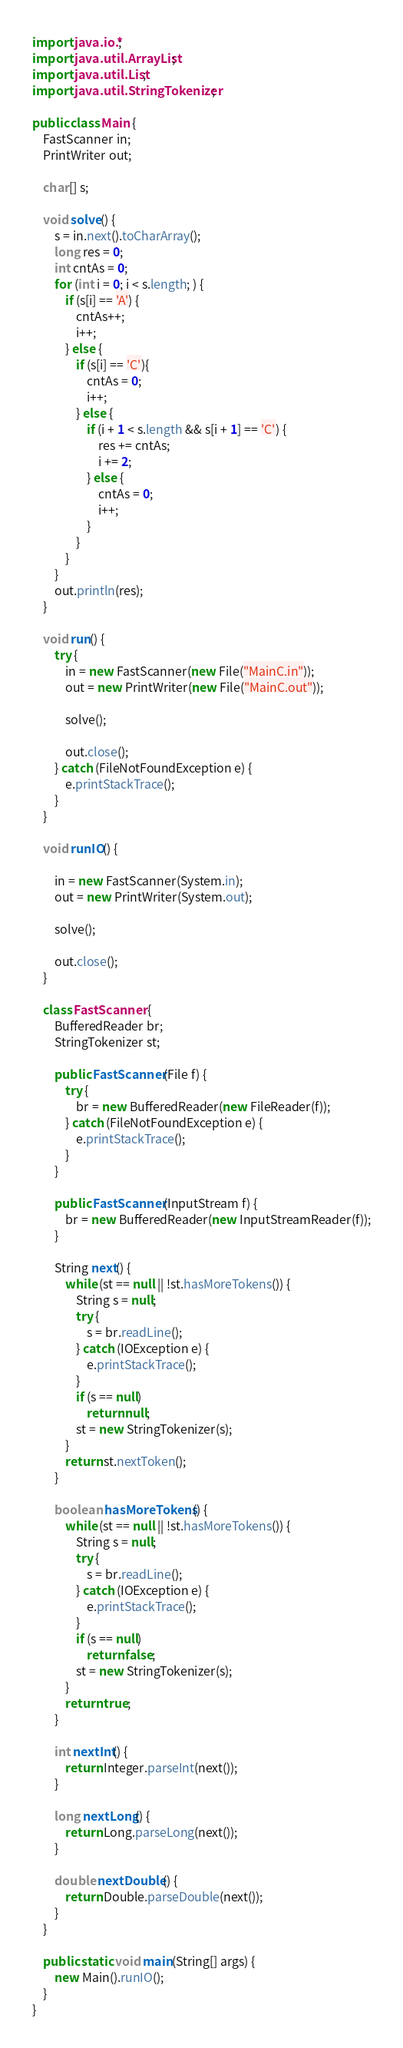<code> <loc_0><loc_0><loc_500><loc_500><_Java_>import java.io.*;
import java.util.ArrayList;
import java.util.List;
import java.util.StringTokenizer;

public class Main {
    FastScanner in;
    PrintWriter out;

    char[] s;

    void solve() {
        s = in.next().toCharArray();
        long res = 0;
        int cntAs = 0;
        for (int i = 0; i < s.length; ) {
            if (s[i] == 'A') {
                cntAs++;
                i++;
            } else {
                if (s[i] == 'C'){
                    cntAs = 0;
                    i++;
                } else {
                    if (i + 1 < s.length && s[i + 1] == 'C') {
                        res += cntAs;
                        i += 2;
                    } else {
                        cntAs = 0;
                        i++;
                    }
                }
            }
        }
        out.println(res);
    }

    void run() {
        try {
            in = new FastScanner(new File("MainC.in"));
            out = new PrintWriter(new File("MainC.out"));

            solve();

            out.close();
        } catch (FileNotFoundException e) {
            e.printStackTrace();
        }
    }

    void runIO() {

        in = new FastScanner(System.in);
        out = new PrintWriter(System.out);

        solve();

        out.close();
    }

    class FastScanner {
        BufferedReader br;
        StringTokenizer st;

        public FastScanner(File f) {
            try {
                br = new BufferedReader(new FileReader(f));
            } catch (FileNotFoundException e) {
                e.printStackTrace();
            }
        }

        public FastScanner(InputStream f) {
            br = new BufferedReader(new InputStreamReader(f));
        }

        String next() {
            while (st == null || !st.hasMoreTokens()) {
                String s = null;
                try {
                    s = br.readLine();
                } catch (IOException e) {
                    e.printStackTrace();
                }
                if (s == null)
                    return null;
                st = new StringTokenizer(s);
            }
            return st.nextToken();
        }

        boolean hasMoreTokens() {
            while (st == null || !st.hasMoreTokens()) {
                String s = null;
                try {
                    s = br.readLine();
                } catch (IOException e) {
                    e.printStackTrace();
                }
                if (s == null)
                    return false;
                st = new StringTokenizer(s);
            }
            return true;
        }

        int nextInt() {
            return Integer.parseInt(next());
        }

        long nextLong() {
            return Long.parseLong(next());
        }

        double nextDouble() {
            return Double.parseDouble(next());
        }
    }

    public static void main(String[] args) {
        new Main().runIO();
    }
}
</code> 